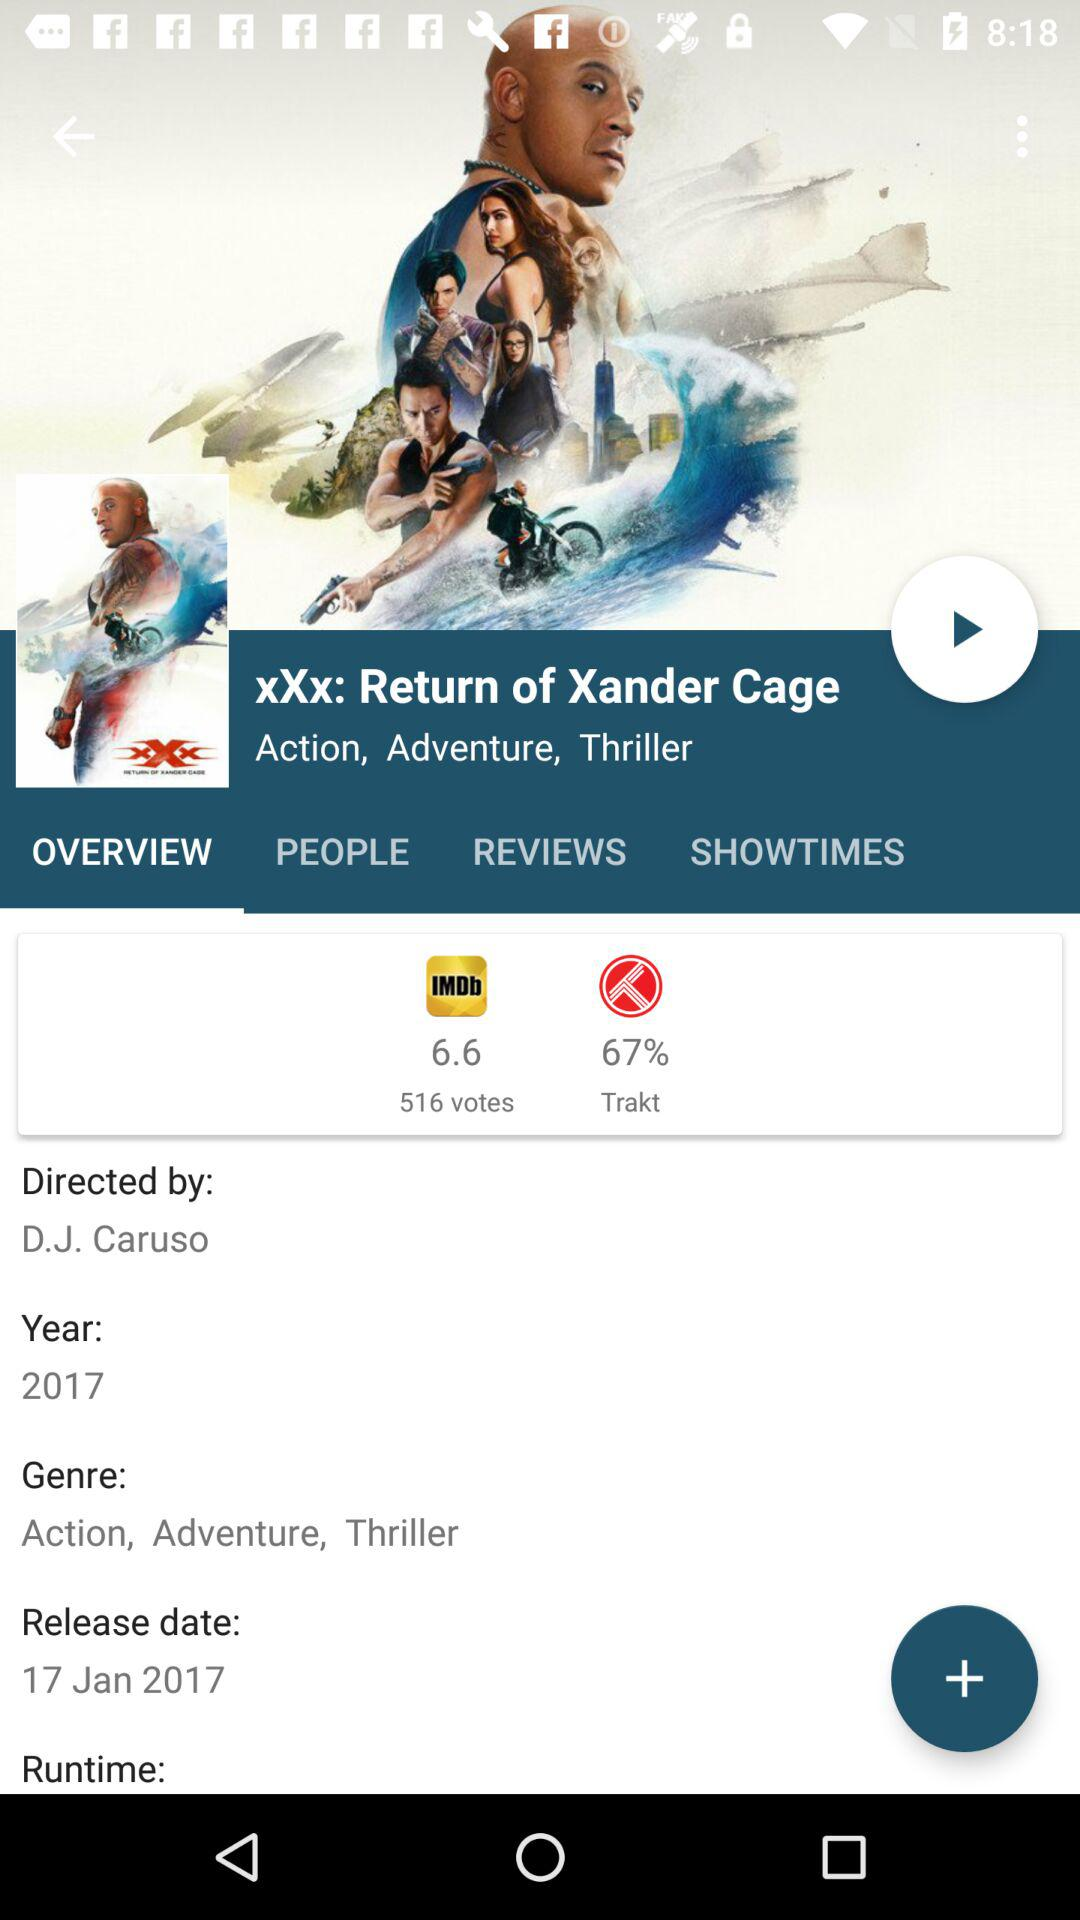What is the percentage of Trakt? The percentage is 67. 